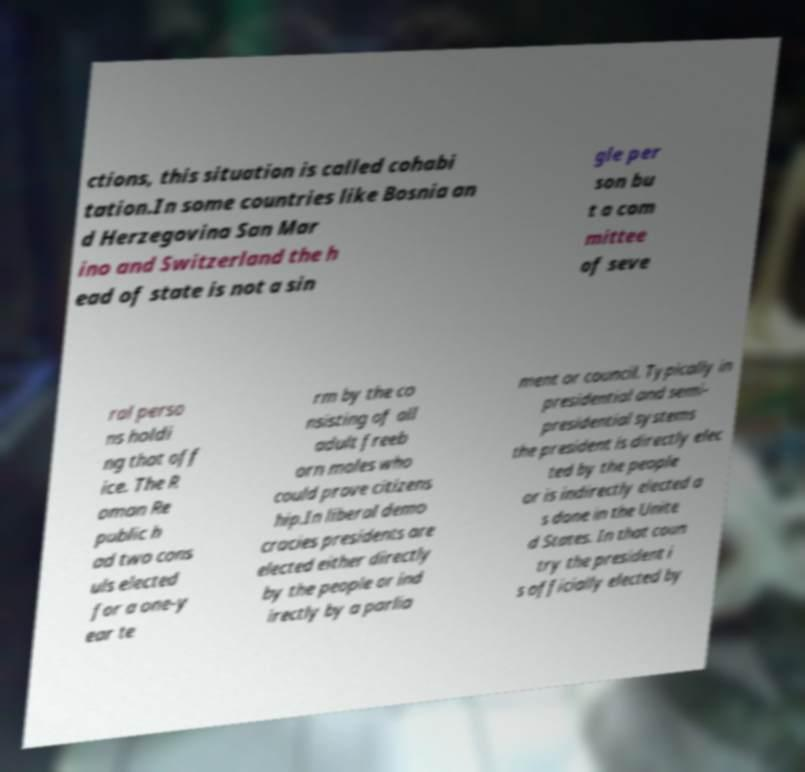Could you assist in decoding the text presented in this image and type it out clearly? ctions, this situation is called cohabi tation.In some countries like Bosnia an d Herzegovina San Mar ino and Switzerland the h ead of state is not a sin gle per son bu t a com mittee of seve ral perso ns holdi ng that off ice. The R oman Re public h ad two cons uls elected for a one-y ear te rm by the co nsisting of all adult freeb orn males who could prove citizens hip.In liberal demo cracies presidents are elected either directly by the people or ind irectly by a parlia ment or council. Typically in presidential and semi- presidential systems the president is directly elec ted by the people or is indirectly elected a s done in the Unite d States. In that coun try the president i s officially elected by 